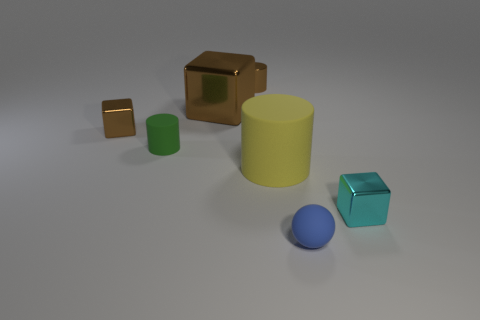Is there anything else that has the same color as the small rubber sphere?
Offer a terse response. No. Is there a small metal object that is behind the matte cylinder to the right of the big brown block that is behind the big yellow cylinder?
Your answer should be compact. Yes. What color is the big block?
Your answer should be compact. Brown. There is a tiny matte ball; are there any shiny cylinders in front of it?
Give a very brief answer. No. Does the small blue rubber object have the same shape as the small rubber object that is behind the tiny cyan thing?
Provide a succinct answer. No. How many other things are the same material as the small cyan cube?
Offer a terse response. 3. The small object on the right side of the rubber object in front of the tiny object that is to the right of the blue rubber thing is what color?
Offer a very short reply. Cyan. There is a large brown thing behind the small shiny block behind the cyan metallic object; what is its shape?
Provide a succinct answer. Cube. Are there more rubber balls right of the cyan metal object than big purple blocks?
Your response must be concise. No. There is a small brown metallic thing that is to the right of the large brown metal thing; is it the same shape as the small green thing?
Offer a very short reply. Yes. 